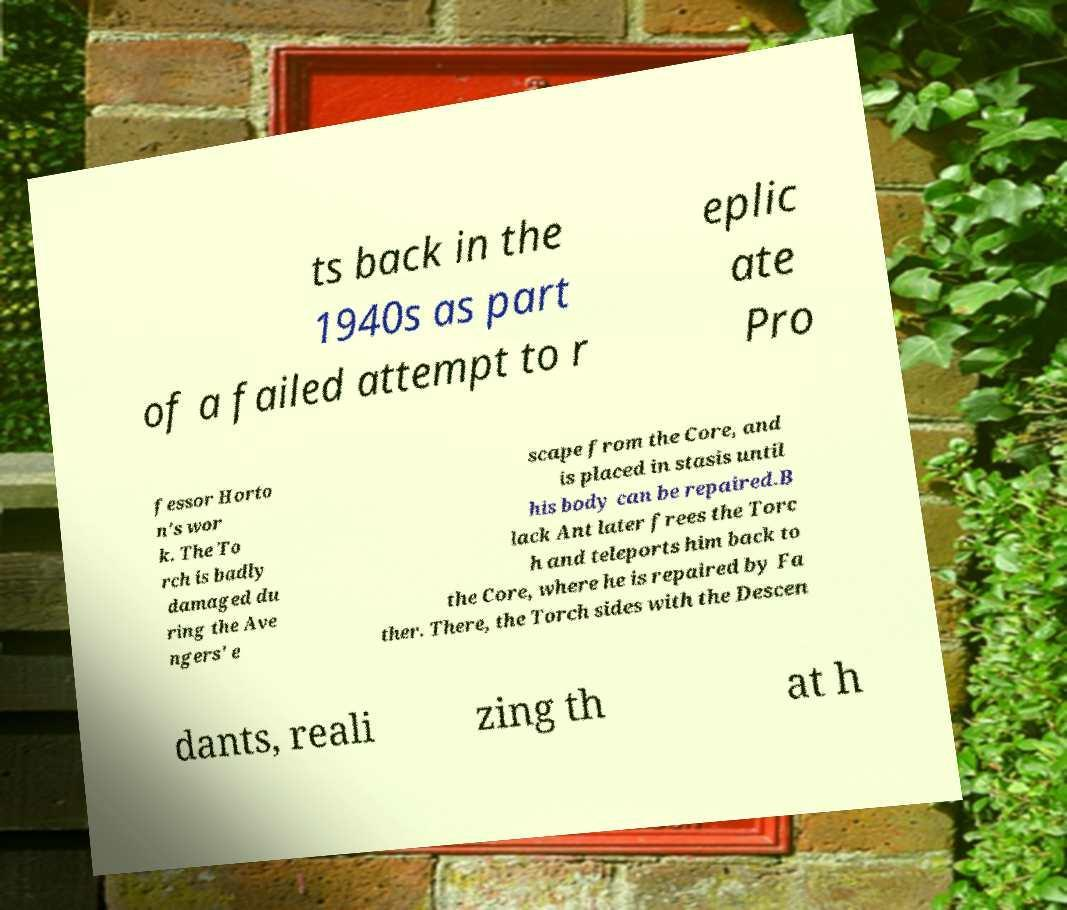Can you read and provide the text displayed in the image?This photo seems to have some interesting text. Can you extract and type it out for me? ts back in the 1940s as part of a failed attempt to r eplic ate Pro fessor Horto n's wor k. The To rch is badly damaged du ring the Ave ngers' e scape from the Core, and is placed in stasis until his body can be repaired.B lack Ant later frees the Torc h and teleports him back to the Core, where he is repaired by Fa ther. There, the Torch sides with the Descen dants, reali zing th at h 